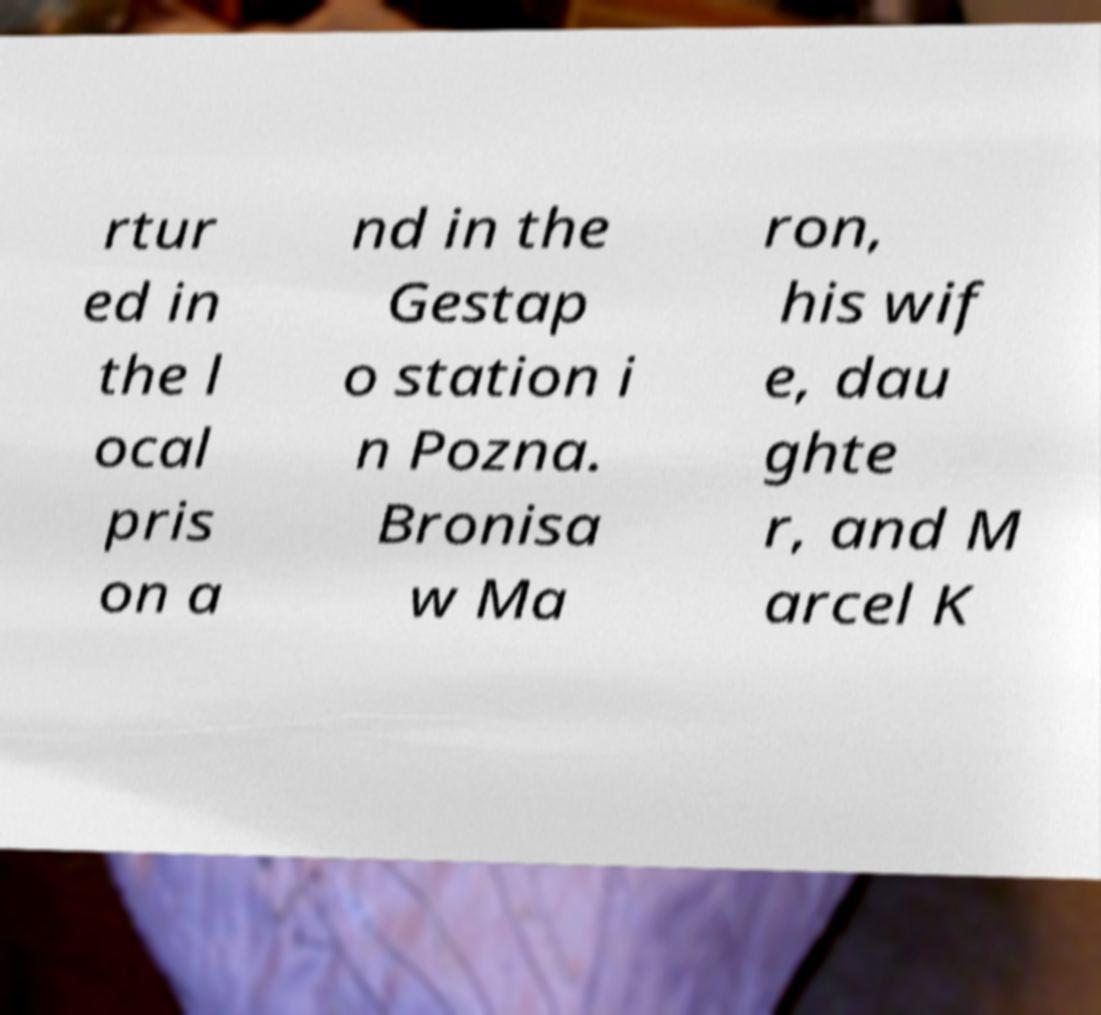Can you read and provide the text displayed in the image?This photo seems to have some interesting text. Can you extract and type it out for me? rtur ed in the l ocal pris on a nd in the Gestap o station i n Pozna. Bronisa w Ma ron, his wif e, dau ghte r, and M arcel K 